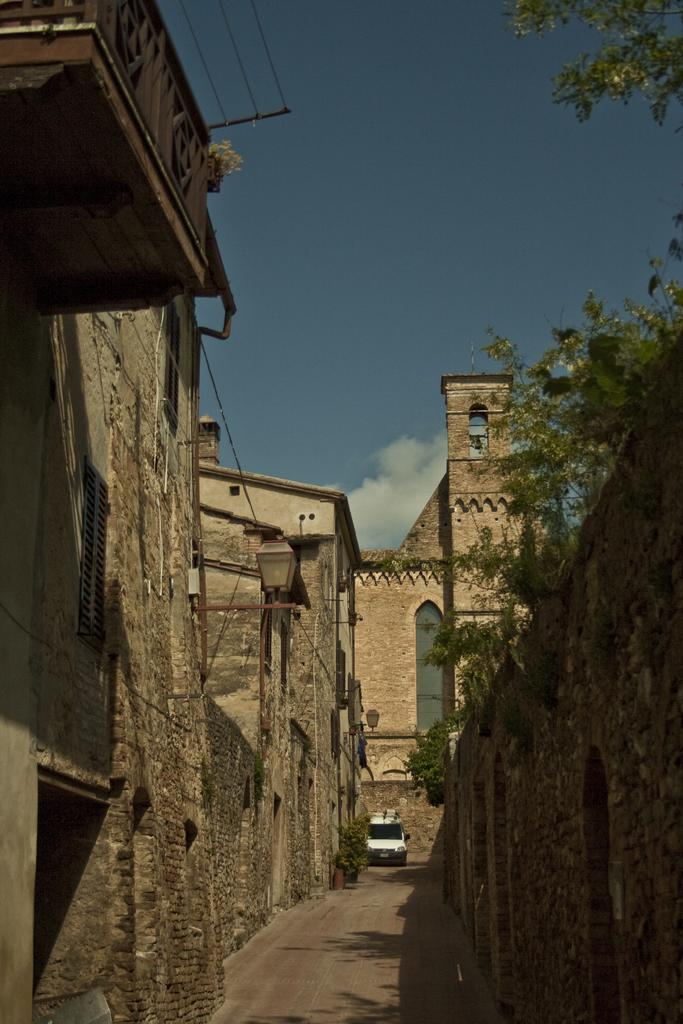What is the main subject of the image? The main subject of the image is a car on the road. What else can be seen in the image besides the car? There are trees, lamps, buildings with windows, and the sky with clouds visible in the image. Can you describe the buildings in the image? The buildings in the image have windows. What is the condition of the sky in the image? The sky in the image has clouds visible in the background. How does the earthquake affect the car in the image? There is no earthquake present in the image, so its effect on the car cannot be determined. 